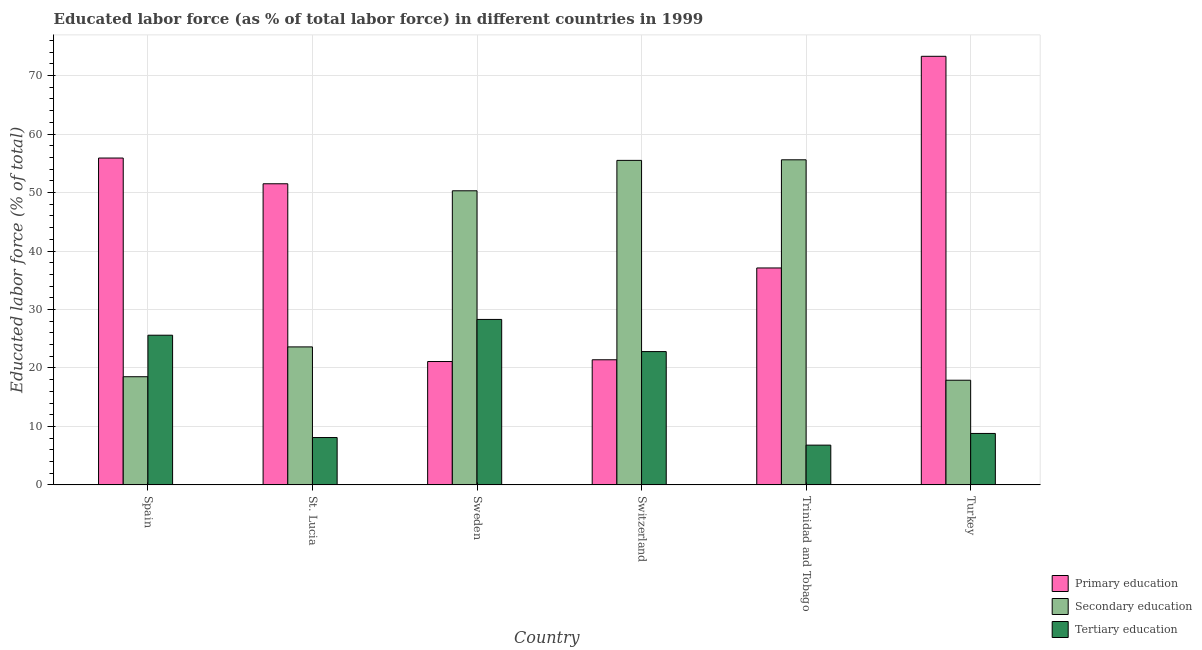Are the number of bars per tick equal to the number of legend labels?
Ensure brevity in your answer.  Yes. What is the percentage of labor force who received secondary education in Trinidad and Tobago?
Keep it short and to the point. 55.6. Across all countries, what is the maximum percentage of labor force who received primary education?
Provide a short and direct response. 73.3. Across all countries, what is the minimum percentage of labor force who received secondary education?
Provide a short and direct response. 17.9. In which country was the percentage of labor force who received secondary education maximum?
Make the answer very short. Trinidad and Tobago. In which country was the percentage of labor force who received primary education minimum?
Make the answer very short. Sweden. What is the total percentage of labor force who received secondary education in the graph?
Make the answer very short. 221.4. What is the difference between the percentage of labor force who received secondary education in Spain and that in Sweden?
Your answer should be very brief. -31.8. What is the average percentage of labor force who received tertiary education per country?
Give a very brief answer. 16.73. What is the difference between the percentage of labor force who received secondary education and percentage of labor force who received primary education in St. Lucia?
Provide a succinct answer. -27.9. In how many countries, is the percentage of labor force who received secondary education greater than 36 %?
Offer a terse response. 3. What is the ratio of the percentage of labor force who received primary education in Trinidad and Tobago to that in Turkey?
Provide a short and direct response. 0.51. Is the difference between the percentage of labor force who received primary education in St. Lucia and Trinidad and Tobago greater than the difference between the percentage of labor force who received tertiary education in St. Lucia and Trinidad and Tobago?
Provide a succinct answer. Yes. What is the difference between the highest and the second highest percentage of labor force who received secondary education?
Provide a succinct answer. 0.1. What is the difference between the highest and the lowest percentage of labor force who received secondary education?
Provide a succinct answer. 37.7. In how many countries, is the percentage of labor force who received primary education greater than the average percentage of labor force who received primary education taken over all countries?
Provide a short and direct response. 3. What does the 3rd bar from the left in Switzerland represents?
Offer a terse response. Tertiary education. What does the 2nd bar from the right in Sweden represents?
Provide a short and direct response. Secondary education. How many bars are there?
Ensure brevity in your answer.  18. Are all the bars in the graph horizontal?
Offer a very short reply. No. How many countries are there in the graph?
Your response must be concise. 6. Are the values on the major ticks of Y-axis written in scientific E-notation?
Offer a very short reply. No. Does the graph contain any zero values?
Keep it short and to the point. No. Does the graph contain grids?
Your response must be concise. Yes. How many legend labels are there?
Your response must be concise. 3. How are the legend labels stacked?
Ensure brevity in your answer.  Vertical. What is the title of the graph?
Your response must be concise. Educated labor force (as % of total labor force) in different countries in 1999. What is the label or title of the X-axis?
Offer a very short reply. Country. What is the label or title of the Y-axis?
Provide a short and direct response. Educated labor force (% of total). What is the Educated labor force (% of total) of Primary education in Spain?
Provide a short and direct response. 55.9. What is the Educated labor force (% of total) of Tertiary education in Spain?
Your answer should be very brief. 25.6. What is the Educated labor force (% of total) in Primary education in St. Lucia?
Give a very brief answer. 51.5. What is the Educated labor force (% of total) in Secondary education in St. Lucia?
Give a very brief answer. 23.6. What is the Educated labor force (% of total) of Tertiary education in St. Lucia?
Keep it short and to the point. 8.1. What is the Educated labor force (% of total) in Primary education in Sweden?
Your answer should be very brief. 21.1. What is the Educated labor force (% of total) of Secondary education in Sweden?
Ensure brevity in your answer.  50.3. What is the Educated labor force (% of total) in Tertiary education in Sweden?
Provide a short and direct response. 28.3. What is the Educated labor force (% of total) in Primary education in Switzerland?
Offer a very short reply. 21.4. What is the Educated labor force (% of total) in Secondary education in Switzerland?
Give a very brief answer. 55.5. What is the Educated labor force (% of total) in Tertiary education in Switzerland?
Give a very brief answer. 22.8. What is the Educated labor force (% of total) of Primary education in Trinidad and Tobago?
Your response must be concise. 37.1. What is the Educated labor force (% of total) of Secondary education in Trinidad and Tobago?
Make the answer very short. 55.6. What is the Educated labor force (% of total) of Tertiary education in Trinidad and Tobago?
Keep it short and to the point. 6.8. What is the Educated labor force (% of total) in Primary education in Turkey?
Your answer should be very brief. 73.3. What is the Educated labor force (% of total) in Secondary education in Turkey?
Make the answer very short. 17.9. What is the Educated labor force (% of total) in Tertiary education in Turkey?
Offer a very short reply. 8.8. Across all countries, what is the maximum Educated labor force (% of total) of Primary education?
Ensure brevity in your answer.  73.3. Across all countries, what is the maximum Educated labor force (% of total) in Secondary education?
Your answer should be compact. 55.6. Across all countries, what is the maximum Educated labor force (% of total) in Tertiary education?
Offer a terse response. 28.3. Across all countries, what is the minimum Educated labor force (% of total) in Primary education?
Provide a succinct answer. 21.1. Across all countries, what is the minimum Educated labor force (% of total) in Secondary education?
Your answer should be compact. 17.9. Across all countries, what is the minimum Educated labor force (% of total) in Tertiary education?
Provide a short and direct response. 6.8. What is the total Educated labor force (% of total) of Primary education in the graph?
Ensure brevity in your answer.  260.3. What is the total Educated labor force (% of total) of Secondary education in the graph?
Ensure brevity in your answer.  221.4. What is the total Educated labor force (% of total) in Tertiary education in the graph?
Ensure brevity in your answer.  100.4. What is the difference between the Educated labor force (% of total) of Primary education in Spain and that in St. Lucia?
Ensure brevity in your answer.  4.4. What is the difference between the Educated labor force (% of total) of Secondary education in Spain and that in St. Lucia?
Your answer should be very brief. -5.1. What is the difference between the Educated labor force (% of total) of Primary education in Spain and that in Sweden?
Offer a terse response. 34.8. What is the difference between the Educated labor force (% of total) of Secondary education in Spain and that in Sweden?
Provide a succinct answer. -31.8. What is the difference between the Educated labor force (% of total) of Primary education in Spain and that in Switzerland?
Offer a terse response. 34.5. What is the difference between the Educated labor force (% of total) in Secondary education in Spain and that in Switzerland?
Make the answer very short. -37. What is the difference between the Educated labor force (% of total) in Tertiary education in Spain and that in Switzerland?
Make the answer very short. 2.8. What is the difference between the Educated labor force (% of total) of Primary education in Spain and that in Trinidad and Tobago?
Offer a terse response. 18.8. What is the difference between the Educated labor force (% of total) of Secondary education in Spain and that in Trinidad and Tobago?
Provide a short and direct response. -37.1. What is the difference between the Educated labor force (% of total) of Primary education in Spain and that in Turkey?
Provide a short and direct response. -17.4. What is the difference between the Educated labor force (% of total) in Primary education in St. Lucia and that in Sweden?
Make the answer very short. 30.4. What is the difference between the Educated labor force (% of total) in Secondary education in St. Lucia and that in Sweden?
Offer a very short reply. -26.7. What is the difference between the Educated labor force (% of total) of Tertiary education in St. Lucia and that in Sweden?
Ensure brevity in your answer.  -20.2. What is the difference between the Educated labor force (% of total) of Primary education in St. Lucia and that in Switzerland?
Your answer should be compact. 30.1. What is the difference between the Educated labor force (% of total) in Secondary education in St. Lucia and that in Switzerland?
Offer a terse response. -31.9. What is the difference between the Educated labor force (% of total) of Tertiary education in St. Lucia and that in Switzerland?
Provide a succinct answer. -14.7. What is the difference between the Educated labor force (% of total) in Primary education in St. Lucia and that in Trinidad and Tobago?
Make the answer very short. 14.4. What is the difference between the Educated labor force (% of total) in Secondary education in St. Lucia and that in Trinidad and Tobago?
Make the answer very short. -32. What is the difference between the Educated labor force (% of total) in Tertiary education in St. Lucia and that in Trinidad and Tobago?
Offer a terse response. 1.3. What is the difference between the Educated labor force (% of total) in Primary education in St. Lucia and that in Turkey?
Give a very brief answer. -21.8. What is the difference between the Educated labor force (% of total) in Secondary education in Sweden and that in Switzerland?
Your response must be concise. -5.2. What is the difference between the Educated labor force (% of total) of Tertiary education in Sweden and that in Switzerland?
Keep it short and to the point. 5.5. What is the difference between the Educated labor force (% of total) of Primary education in Sweden and that in Turkey?
Give a very brief answer. -52.2. What is the difference between the Educated labor force (% of total) in Secondary education in Sweden and that in Turkey?
Make the answer very short. 32.4. What is the difference between the Educated labor force (% of total) in Primary education in Switzerland and that in Trinidad and Tobago?
Make the answer very short. -15.7. What is the difference between the Educated labor force (% of total) in Tertiary education in Switzerland and that in Trinidad and Tobago?
Your answer should be very brief. 16. What is the difference between the Educated labor force (% of total) in Primary education in Switzerland and that in Turkey?
Offer a very short reply. -51.9. What is the difference between the Educated labor force (% of total) of Secondary education in Switzerland and that in Turkey?
Make the answer very short. 37.6. What is the difference between the Educated labor force (% of total) of Tertiary education in Switzerland and that in Turkey?
Make the answer very short. 14. What is the difference between the Educated labor force (% of total) of Primary education in Trinidad and Tobago and that in Turkey?
Make the answer very short. -36.2. What is the difference between the Educated labor force (% of total) of Secondary education in Trinidad and Tobago and that in Turkey?
Give a very brief answer. 37.7. What is the difference between the Educated labor force (% of total) of Primary education in Spain and the Educated labor force (% of total) of Secondary education in St. Lucia?
Provide a short and direct response. 32.3. What is the difference between the Educated labor force (% of total) of Primary education in Spain and the Educated labor force (% of total) of Tertiary education in St. Lucia?
Offer a very short reply. 47.8. What is the difference between the Educated labor force (% of total) in Primary education in Spain and the Educated labor force (% of total) in Secondary education in Sweden?
Ensure brevity in your answer.  5.6. What is the difference between the Educated labor force (% of total) of Primary education in Spain and the Educated labor force (% of total) of Tertiary education in Sweden?
Ensure brevity in your answer.  27.6. What is the difference between the Educated labor force (% of total) in Primary education in Spain and the Educated labor force (% of total) in Tertiary education in Switzerland?
Make the answer very short. 33.1. What is the difference between the Educated labor force (% of total) of Primary education in Spain and the Educated labor force (% of total) of Tertiary education in Trinidad and Tobago?
Your response must be concise. 49.1. What is the difference between the Educated labor force (% of total) of Primary education in Spain and the Educated labor force (% of total) of Tertiary education in Turkey?
Give a very brief answer. 47.1. What is the difference between the Educated labor force (% of total) in Secondary education in Spain and the Educated labor force (% of total) in Tertiary education in Turkey?
Your answer should be compact. 9.7. What is the difference between the Educated labor force (% of total) of Primary education in St. Lucia and the Educated labor force (% of total) of Secondary education in Sweden?
Give a very brief answer. 1.2. What is the difference between the Educated labor force (% of total) of Primary education in St. Lucia and the Educated labor force (% of total) of Tertiary education in Sweden?
Give a very brief answer. 23.2. What is the difference between the Educated labor force (% of total) in Secondary education in St. Lucia and the Educated labor force (% of total) in Tertiary education in Sweden?
Make the answer very short. -4.7. What is the difference between the Educated labor force (% of total) in Primary education in St. Lucia and the Educated labor force (% of total) in Secondary education in Switzerland?
Ensure brevity in your answer.  -4. What is the difference between the Educated labor force (% of total) in Primary education in St. Lucia and the Educated labor force (% of total) in Tertiary education in Switzerland?
Your answer should be very brief. 28.7. What is the difference between the Educated labor force (% of total) in Secondary education in St. Lucia and the Educated labor force (% of total) in Tertiary education in Switzerland?
Keep it short and to the point. 0.8. What is the difference between the Educated labor force (% of total) of Primary education in St. Lucia and the Educated labor force (% of total) of Secondary education in Trinidad and Tobago?
Ensure brevity in your answer.  -4.1. What is the difference between the Educated labor force (% of total) in Primary education in St. Lucia and the Educated labor force (% of total) in Tertiary education in Trinidad and Tobago?
Provide a succinct answer. 44.7. What is the difference between the Educated labor force (% of total) of Secondary education in St. Lucia and the Educated labor force (% of total) of Tertiary education in Trinidad and Tobago?
Your answer should be compact. 16.8. What is the difference between the Educated labor force (% of total) of Primary education in St. Lucia and the Educated labor force (% of total) of Secondary education in Turkey?
Offer a terse response. 33.6. What is the difference between the Educated labor force (% of total) of Primary education in St. Lucia and the Educated labor force (% of total) of Tertiary education in Turkey?
Your response must be concise. 42.7. What is the difference between the Educated labor force (% of total) in Secondary education in St. Lucia and the Educated labor force (% of total) in Tertiary education in Turkey?
Keep it short and to the point. 14.8. What is the difference between the Educated labor force (% of total) of Primary education in Sweden and the Educated labor force (% of total) of Secondary education in Switzerland?
Ensure brevity in your answer.  -34.4. What is the difference between the Educated labor force (% of total) of Primary education in Sweden and the Educated labor force (% of total) of Secondary education in Trinidad and Tobago?
Make the answer very short. -34.5. What is the difference between the Educated labor force (% of total) in Secondary education in Sweden and the Educated labor force (% of total) in Tertiary education in Trinidad and Tobago?
Keep it short and to the point. 43.5. What is the difference between the Educated labor force (% of total) of Secondary education in Sweden and the Educated labor force (% of total) of Tertiary education in Turkey?
Your answer should be compact. 41.5. What is the difference between the Educated labor force (% of total) of Primary education in Switzerland and the Educated labor force (% of total) of Secondary education in Trinidad and Tobago?
Ensure brevity in your answer.  -34.2. What is the difference between the Educated labor force (% of total) in Secondary education in Switzerland and the Educated labor force (% of total) in Tertiary education in Trinidad and Tobago?
Your response must be concise. 48.7. What is the difference between the Educated labor force (% of total) in Primary education in Switzerland and the Educated labor force (% of total) in Secondary education in Turkey?
Give a very brief answer. 3.5. What is the difference between the Educated labor force (% of total) of Primary education in Switzerland and the Educated labor force (% of total) of Tertiary education in Turkey?
Your answer should be very brief. 12.6. What is the difference between the Educated labor force (% of total) in Secondary education in Switzerland and the Educated labor force (% of total) in Tertiary education in Turkey?
Make the answer very short. 46.7. What is the difference between the Educated labor force (% of total) in Primary education in Trinidad and Tobago and the Educated labor force (% of total) in Secondary education in Turkey?
Your response must be concise. 19.2. What is the difference between the Educated labor force (% of total) in Primary education in Trinidad and Tobago and the Educated labor force (% of total) in Tertiary education in Turkey?
Your response must be concise. 28.3. What is the difference between the Educated labor force (% of total) in Secondary education in Trinidad and Tobago and the Educated labor force (% of total) in Tertiary education in Turkey?
Offer a very short reply. 46.8. What is the average Educated labor force (% of total) in Primary education per country?
Your answer should be very brief. 43.38. What is the average Educated labor force (% of total) of Secondary education per country?
Provide a short and direct response. 36.9. What is the average Educated labor force (% of total) of Tertiary education per country?
Your response must be concise. 16.73. What is the difference between the Educated labor force (% of total) of Primary education and Educated labor force (% of total) of Secondary education in Spain?
Offer a terse response. 37.4. What is the difference between the Educated labor force (% of total) in Primary education and Educated labor force (% of total) in Tertiary education in Spain?
Provide a short and direct response. 30.3. What is the difference between the Educated labor force (% of total) in Primary education and Educated labor force (% of total) in Secondary education in St. Lucia?
Give a very brief answer. 27.9. What is the difference between the Educated labor force (% of total) in Primary education and Educated labor force (% of total) in Tertiary education in St. Lucia?
Offer a terse response. 43.4. What is the difference between the Educated labor force (% of total) of Primary education and Educated labor force (% of total) of Secondary education in Sweden?
Keep it short and to the point. -29.2. What is the difference between the Educated labor force (% of total) of Primary education and Educated labor force (% of total) of Secondary education in Switzerland?
Keep it short and to the point. -34.1. What is the difference between the Educated labor force (% of total) in Primary education and Educated labor force (% of total) in Tertiary education in Switzerland?
Provide a succinct answer. -1.4. What is the difference between the Educated labor force (% of total) of Secondary education and Educated labor force (% of total) of Tertiary education in Switzerland?
Your answer should be compact. 32.7. What is the difference between the Educated labor force (% of total) of Primary education and Educated labor force (% of total) of Secondary education in Trinidad and Tobago?
Keep it short and to the point. -18.5. What is the difference between the Educated labor force (% of total) of Primary education and Educated labor force (% of total) of Tertiary education in Trinidad and Tobago?
Offer a very short reply. 30.3. What is the difference between the Educated labor force (% of total) of Secondary education and Educated labor force (% of total) of Tertiary education in Trinidad and Tobago?
Your response must be concise. 48.8. What is the difference between the Educated labor force (% of total) in Primary education and Educated labor force (% of total) in Secondary education in Turkey?
Your answer should be compact. 55.4. What is the difference between the Educated labor force (% of total) of Primary education and Educated labor force (% of total) of Tertiary education in Turkey?
Give a very brief answer. 64.5. What is the difference between the Educated labor force (% of total) in Secondary education and Educated labor force (% of total) in Tertiary education in Turkey?
Your response must be concise. 9.1. What is the ratio of the Educated labor force (% of total) in Primary education in Spain to that in St. Lucia?
Offer a very short reply. 1.09. What is the ratio of the Educated labor force (% of total) in Secondary education in Spain to that in St. Lucia?
Offer a terse response. 0.78. What is the ratio of the Educated labor force (% of total) in Tertiary education in Spain to that in St. Lucia?
Your answer should be very brief. 3.16. What is the ratio of the Educated labor force (% of total) in Primary education in Spain to that in Sweden?
Your answer should be compact. 2.65. What is the ratio of the Educated labor force (% of total) of Secondary education in Spain to that in Sweden?
Provide a succinct answer. 0.37. What is the ratio of the Educated labor force (% of total) of Tertiary education in Spain to that in Sweden?
Your response must be concise. 0.9. What is the ratio of the Educated labor force (% of total) in Primary education in Spain to that in Switzerland?
Offer a terse response. 2.61. What is the ratio of the Educated labor force (% of total) in Secondary education in Spain to that in Switzerland?
Provide a short and direct response. 0.33. What is the ratio of the Educated labor force (% of total) of Tertiary education in Spain to that in Switzerland?
Give a very brief answer. 1.12. What is the ratio of the Educated labor force (% of total) of Primary education in Spain to that in Trinidad and Tobago?
Offer a very short reply. 1.51. What is the ratio of the Educated labor force (% of total) in Secondary education in Spain to that in Trinidad and Tobago?
Keep it short and to the point. 0.33. What is the ratio of the Educated labor force (% of total) in Tertiary education in Spain to that in Trinidad and Tobago?
Give a very brief answer. 3.76. What is the ratio of the Educated labor force (% of total) in Primary education in Spain to that in Turkey?
Give a very brief answer. 0.76. What is the ratio of the Educated labor force (% of total) of Secondary education in Spain to that in Turkey?
Offer a very short reply. 1.03. What is the ratio of the Educated labor force (% of total) of Tertiary education in Spain to that in Turkey?
Give a very brief answer. 2.91. What is the ratio of the Educated labor force (% of total) of Primary education in St. Lucia to that in Sweden?
Your response must be concise. 2.44. What is the ratio of the Educated labor force (% of total) in Secondary education in St. Lucia to that in Sweden?
Give a very brief answer. 0.47. What is the ratio of the Educated labor force (% of total) of Tertiary education in St. Lucia to that in Sweden?
Provide a short and direct response. 0.29. What is the ratio of the Educated labor force (% of total) of Primary education in St. Lucia to that in Switzerland?
Provide a succinct answer. 2.41. What is the ratio of the Educated labor force (% of total) in Secondary education in St. Lucia to that in Switzerland?
Your answer should be very brief. 0.43. What is the ratio of the Educated labor force (% of total) in Tertiary education in St. Lucia to that in Switzerland?
Offer a very short reply. 0.36. What is the ratio of the Educated labor force (% of total) in Primary education in St. Lucia to that in Trinidad and Tobago?
Provide a succinct answer. 1.39. What is the ratio of the Educated labor force (% of total) in Secondary education in St. Lucia to that in Trinidad and Tobago?
Give a very brief answer. 0.42. What is the ratio of the Educated labor force (% of total) in Tertiary education in St. Lucia to that in Trinidad and Tobago?
Keep it short and to the point. 1.19. What is the ratio of the Educated labor force (% of total) of Primary education in St. Lucia to that in Turkey?
Your response must be concise. 0.7. What is the ratio of the Educated labor force (% of total) in Secondary education in St. Lucia to that in Turkey?
Provide a succinct answer. 1.32. What is the ratio of the Educated labor force (% of total) in Tertiary education in St. Lucia to that in Turkey?
Your answer should be compact. 0.92. What is the ratio of the Educated labor force (% of total) in Secondary education in Sweden to that in Switzerland?
Offer a terse response. 0.91. What is the ratio of the Educated labor force (% of total) in Tertiary education in Sweden to that in Switzerland?
Your response must be concise. 1.24. What is the ratio of the Educated labor force (% of total) in Primary education in Sweden to that in Trinidad and Tobago?
Your answer should be very brief. 0.57. What is the ratio of the Educated labor force (% of total) in Secondary education in Sweden to that in Trinidad and Tobago?
Make the answer very short. 0.9. What is the ratio of the Educated labor force (% of total) of Tertiary education in Sweden to that in Trinidad and Tobago?
Your response must be concise. 4.16. What is the ratio of the Educated labor force (% of total) of Primary education in Sweden to that in Turkey?
Your answer should be compact. 0.29. What is the ratio of the Educated labor force (% of total) in Secondary education in Sweden to that in Turkey?
Your answer should be compact. 2.81. What is the ratio of the Educated labor force (% of total) in Tertiary education in Sweden to that in Turkey?
Your answer should be very brief. 3.22. What is the ratio of the Educated labor force (% of total) of Primary education in Switzerland to that in Trinidad and Tobago?
Provide a succinct answer. 0.58. What is the ratio of the Educated labor force (% of total) of Tertiary education in Switzerland to that in Trinidad and Tobago?
Offer a very short reply. 3.35. What is the ratio of the Educated labor force (% of total) in Primary education in Switzerland to that in Turkey?
Provide a succinct answer. 0.29. What is the ratio of the Educated labor force (% of total) of Secondary education in Switzerland to that in Turkey?
Make the answer very short. 3.1. What is the ratio of the Educated labor force (% of total) of Tertiary education in Switzerland to that in Turkey?
Provide a succinct answer. 2.59. What is the ratio of the Educated labor force (% of total) of Primary education in Trinidad and Tobago to that in Turkey?
Your answer should be very brief. 0.51. What is the ratio of the Educated labor force (% of total) in Secondary education in Trinidad and Tobago to that in Turkey?
Offer a very short reply. 3.11. What is the ratio of the Educated labor force (% of total) of Tertiary education in Trinidad and Tobago to that in Turkey?
Keep it short and to the point. 0.77. What is the difference between the highest and the second highest Educated labor force (% of total) of Primary education?
Keep it short and to the point. 17.4. What is the difference between the highest and the second highest Educated labor force (% of total) of Tertiary education?
Ensure brevity in your answer.  2.7. What is the difference between the highest and the lowest Educated labor force (% of total) in Primary education?
Offer a terse response. 52.2. What is the difference between the highest and the lowest Educated labor force (% of total) in Secondary education?
Make the answer very short. 37.7. What is the difference between the highest and the lowest Educated labor force (% of total) in Tertiary education?
Offer a terse response. 21.5. 